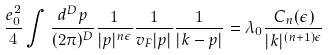<formula> <loc_0><loc_0><loc_500><loc_500>\frac { e ^ { 2 } _ { 0 } } { 4 } \int \frac { d ^ { D } p } { ( 2 \pi ) ^ { D } } \frac { 1 } { | { p } | ^ { n \epsilon } } \frac { 1 } { v _ { F } | { p } | } \frac { 1 } { | { k } - { p } | } = \lambda _ { 0 } \frac { C _ { n } ( \epsilon ) } { | { k } | ^ { ( n + 1 ) \epsilon } }</formula> 